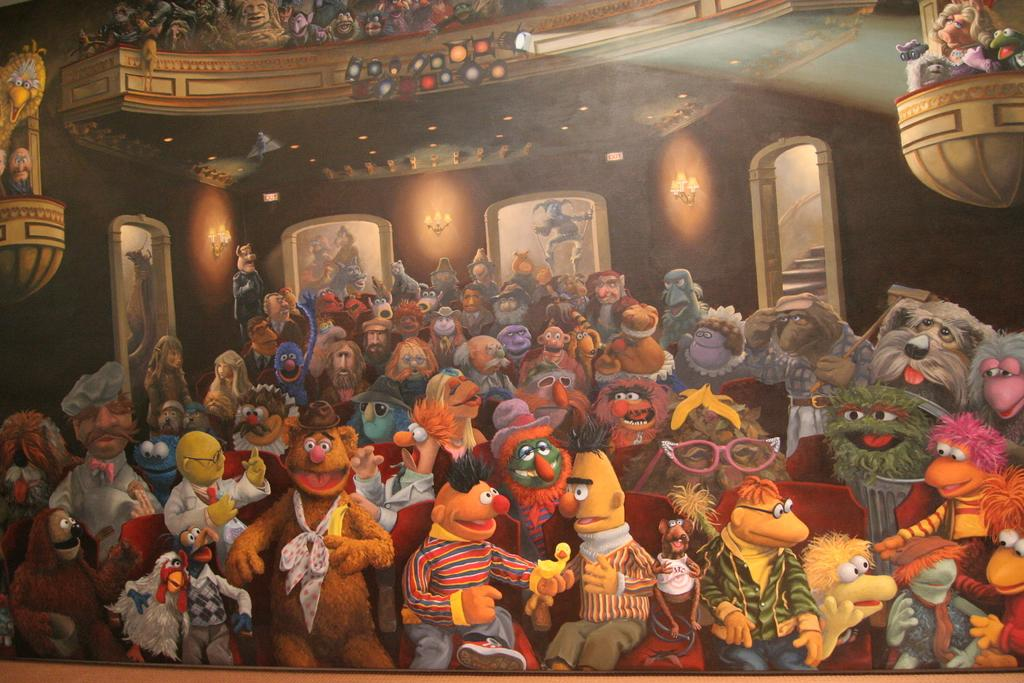What type of image is being described? The image is animated. What objects can be seen in the image? There are toys in the image. Are there any architectural features present in the image? Yes, there are steps in the image. What can be seen on the wall in the image? There are lights on the wall in the image. What type of advertisement is being displayed on the wall in the image? There is no advertisement present in the image; it only features toys, steps, and lights on the wall. How does the image show the effect of gravity on the toys? The image does not show the effect of gravity on the toys; it is an animated image that may not adhere to real-world physics. 